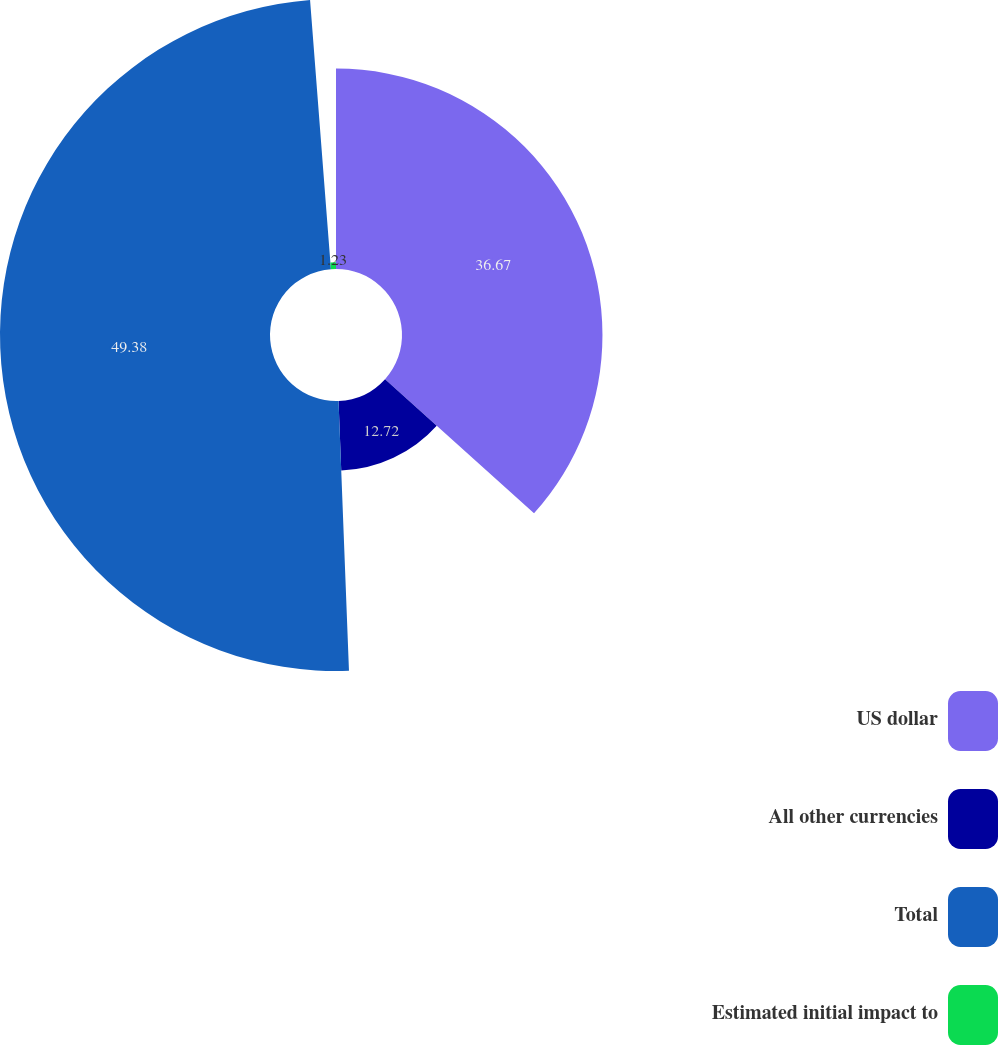<chart> <loc_0><loc_0><loc_500><loc_500><pie_chart><fcel>US dollar<fcel>All other currencies<fcel>Total<fcel>Estimated initial impact to<nl><fcel>36.67%<fcel>12.72%<fcel>49.39%<fcel>1.23%<nl></chart> 